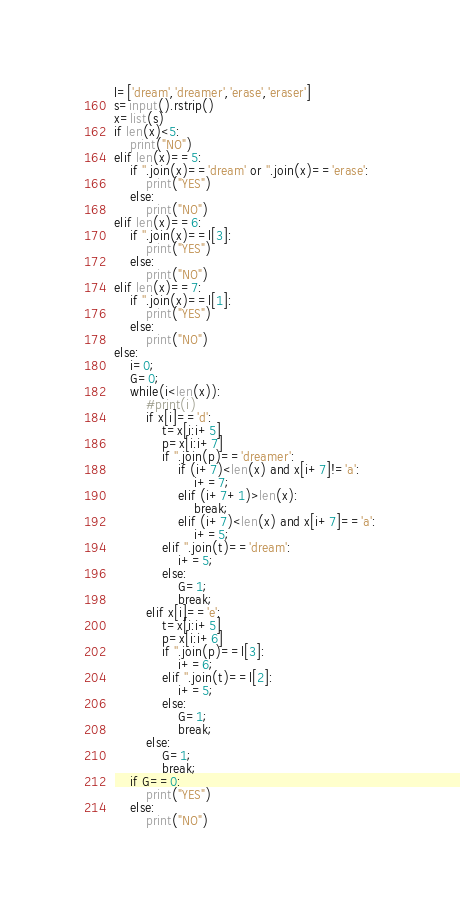<code> <loc_0><loc_0><loc_500><loc_500><_Python_>l=['dream','dreamer','erase','eraser']
s=input().rstrip()
x=list(s)
if len(x)<5:
    print("NO")
elif len(x)==5:
    if ''.join(x)=='dream' or ''.join(x)=='erase':
        print("YES")
    else:
        print("NO")
elif len(x)==6:
    if ''.join(x)==l[3]:
        print("YES")
    else:
        print("NO")
elif len(x)==7:
    if ''.join(x)==l[1]:
        print("YES")
    else:
        print("NO")
else:
    i=0;
    G=0;
    while(i<len(x)):
        #print(i)
        if x[i]=='d':
            t=x[i:i+5]
            p=x[i:i+7]
            if ''.join(p)=='dreamer':
                if (i+7)<len(x) and x[i+7]!='a':
                    i+=7;
                elif (i+7+1)>len(x):
                    break;
                elif (i+7)<len(x) and x[i+7]=='a':
                    i+=5;
            elif ''.join(t)=='dream':
                i+=5;
            else:
                G=1;
                break;
        elif x[i]=='e':
            t=x[i:i+5]
            p=x[i:i+6]
            if ''.join(p)==l[3]:
                i+=6;
            elif ''.join(t)==l[2]:
                i+=5;
            else:
                G=1;
                break;
        else:
            G=1;
            break;
    if G==0:
        print("YES")
    else:
        print("NO")</code> 